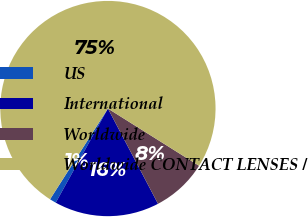Convert chart to OTSL. <chart><loc_0><loc_0><loc_500><loc_500><pie_chart><fcel>US<fcel>International<fcel>Worldwide<fcel>Worldwide CONTACT LENSES /<nl><fcel>0.98%<fcel>15.76%<fcel>8.37%<fcel>74.89%<nl></chart> 